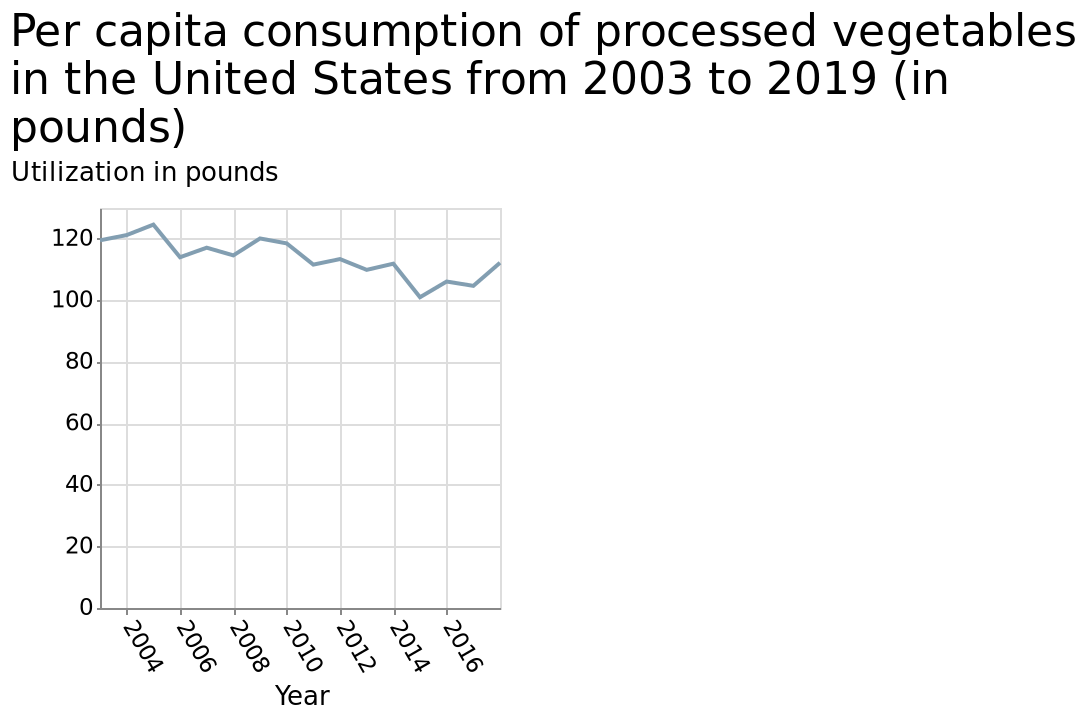<image>
What was the lowest spend recorded?  The lowest spend recorded was 100 pounds in 2015. What does the x-axis in the line chart plot?  The x-axis plots the year. When did the increase in spend occur? The increase in spend occurred after 2016. Was the highest spend recorded 100 pounds in 2015? No. The lowest spend recorded was 100 pounds in 2015. 